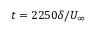<formula> <loc_0><loc_0><loc_500><loc_500>t = 2 2 5 0 \delta / U _ { \infty }</formula> 